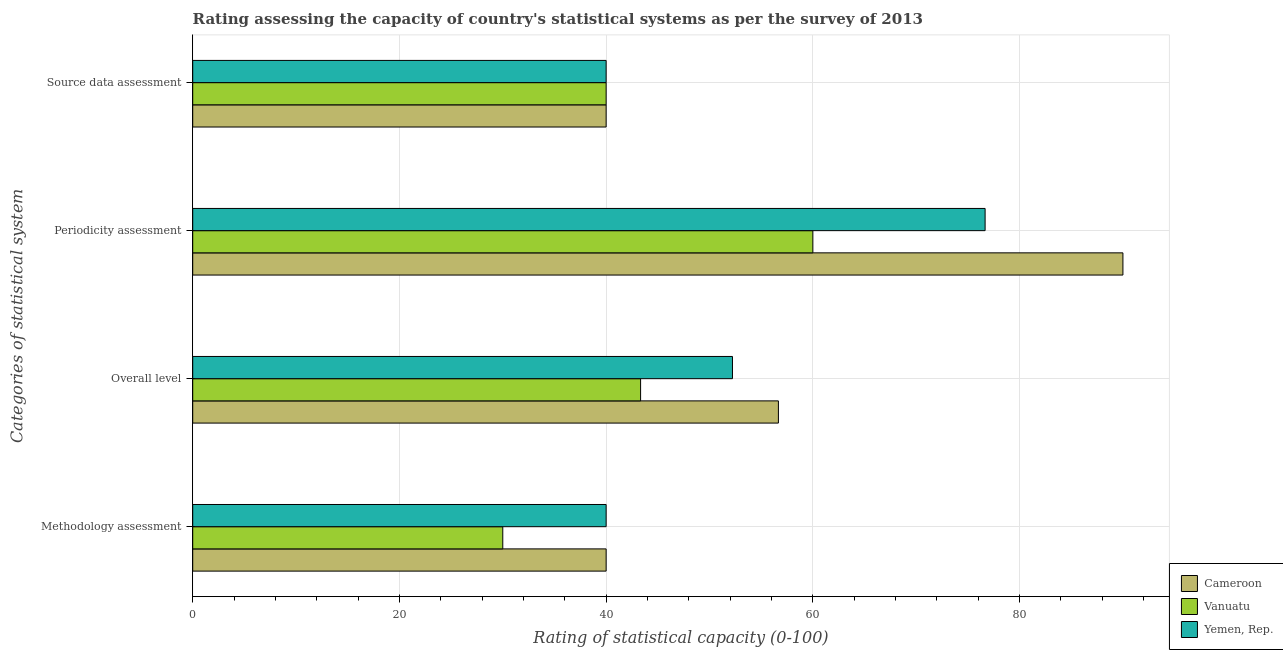How many groups of bars are there?
Provide a succinct answer. 4. Are the number of bars per tick equal to the number of legend labels?
Give a very brief answer. Yes. How many bars are there on the 3rd tick from the bottom?
Ensure brevity in your answer.  3. What is the label of the 2nd group of bars from the top?
Ensure brevity in your answer.  Periodicity assessment. What is the periodicity assessment rating in Yemen, Rep.?
Ensure brevity in your answer.  76.67. Across all countries, what is the minimum source data assessment rating?
Make the answer very short. 40. In which country was the methodology assessment rating maximum?
Provide a short and direct response. Cameroon. In which country was the overall level rating minimum?
Your answer should be compact. Vanuatu. What is the total overall level rating in the graph?
Your answer should be very brief. 152.22. What is the difference between the source data assessment rating in Cameroon and that in Vanuatu?
Give a very brief answer. 0. What is the difference between the methodology assessment rating in Cameroon and the periodicity assessment rating in Yemen, Rep.?
Provide a short and direct response. -36.67. What is the average methodology assessment rating per country?
Provide a short and direct response. 36.67. What is the difference between the overall level rating and source data assessment rating in Vanuatu?
Offer a terse response. 3.33. What is the ratio of the source data assessment rating in Cameroon to that in Yemen, Rep.?
Provide a succinct answer. 1. Is the overall level rating in Yemen, Rep. less than that in Cameroon?
Ensure brevity in your answer.  Yes. What is the difference between the highest and the second highest periodicity assessment rating?
Keep it short and to the point. 13.33. In how many countries, is the overall level rating greater than the average overall level rating taken over all countries?
Ensure brevity in your answer.  2. Is the sum of the periodicity assessment rating in Cameroon and Yemen, Rep. greater than the maximum methodology assessment rating across all countries?
Provide a succinct answer. Yes. Is it the case that in every country, the sum of the overall level rating and periodicity assessment rating is greater than the sum of methodology assessment rating and source data assessment rating?
Keep it short and to the point. No. What does the 1st bar from the top in Overall level represents?
Give a very brief answer. Yemen, Rep. What does the 3rd bar from the bottom in Periodicity assessment represents?
Make the answer very short. Yemen, Rep. How many bars are there?
Your answer should be very brief. 12. Are all the bars in the graph horizontal?
Your answer should be very brief. Yes. What is the difference between two consecutive major ticks on the X-axis?
Make the answer very short. 20. Does the graph contain grids?
Give a very brief answer. Yes. How many legend labels are there?
Ensure brevity in your answer.  3. How are the legend labels stacked?
Provide a short and direct response. Vertical. What is the title of the graph?
Offer a very short reply. Rating assessing the capacity of country's statistical systems as per the survey of 2013 . Does "Equatorial Guinea" appear as one of the legend labels in the graph?
Your response must be concise. No. What is the label or title of the X-axis?
Your response must be concise. Rating of statistical capacity (0-100). What is the label or title of the Y-axis?
Provide a short and direct response. Categories of statistical system. What is the Rating of statistical capacity (0-100) in Vanuatu in Methodology assessment?
Provide a succinct answer. 30. What is the Rating of statistical capacity (0-100) in Yemen, Rep. in Methodology assessment?
Keep it short and to the point. 40. What is the Rating of statistical capacity (0-100) of Cameroon in Overall level?
Provide a succinct answer. 56.67. What is the Rating of statistical capacity (0-100) of Vanuatu in Overall level?
Give a very brief answer. 43.33. What is the Rating of statistical capacity (0-100) of Yemen, Rep. in Overall level?
Your response must be concise. 52.22. What is the Rating of statistical capacity (0-100) of Cameroon in Periodicity assessment?
Your answer should be very brief. 90. What is the Rating of statistical capacity (0-100) in Vanuatu in Periodicity assessment?
Provide a short and direct response. 60. What is the Rating of statistical capacity (0-100) of Yemen, Rep. in Periodicity assessment?
Offer a terse response. 76.67. What is the Rating of statistical capacity (0-100) in Vanuatu in Source data assessment?
Keep it short and to the point. 40. Across all Categories of statistical system, what is the maximum Rating of statistical capacity (0-100) in Yemen, Rep.?
Your answer should be very brief. 76.67. Across all Categories of statistical system, what is the minimum Rating of statistical capacity (0-100) in Cameroon?
Provide a short and direct response. 40. Across all Categories of statistical system, what is the minimum Rating of statistical capacity (0-100) of Vanuatu?
Ensure brevity in your answer.  30. Across all Categories of statistical system, what is the minimum Rating of statistical capacity (0-100) in Yemen, Rep.?
Offer a terse response. 40. What is the total Rating of statistical capacity (0-100) in Cameroon in the graph?
Make the answer very short. 226.67. What is the total Rating of statistical capacity (0-100) in Vanuatu in the graph?
Keep it short and to the point. 173.33. What is the total Rating of statistical capacity (0-100) of Yemen, Rep. in the graph?
Your answer should be very brief. 208.89. What is the difference between the Rating of statistical capacity (0-100) of Cameroon in Methodology assessment and that in Overall level?
Your response must be concise. -16.67. What is the difference between the Rating of statistical capacity (0-100) of Vanuatu in Methodology assessment and that in Overall level?
Ensure brevity in your answer.  -13.33. What is the difference between the Rating of statistical capacity (0-100) in Yemen, Rep. in Methodology assessment and that in Overall level?
Keep it short and to the point. -12.22. What is the difference between the Rating of statistical capacity (0-100) of Vanuatu in Methodology assessment and that in Periodicity assessment?
Your answer should be very brief. -30. What is the difference between the Rating of statistical capacity (0-100) of Yemen, Rep. in Methodology assessment and that in Periodicity assessment?
Your answer should be very brief. -36.67. What is the difference between the Rating of statistical capacity (0-100) in Cameroon in Methodology assessment and that in Source data assessment?
Keep it short and to the point. 0. What is the difference between the Rating of statistical capacity (0-100) in Vanuatu in Methodology assessment and that in Source data assessment?
Offer a very short reply. -10. What is the difference between the Rating of statistical capacity (0-100) of Yemen, Rep. in Methodology assessment and that in Source data assessment?
Offer a terse response. 0. What is the difference between the Rating of statistical capacity (0-100) in Cameroon in Overall level and that in Periodicity assessment?
Offer a very short reply. -33.33. What is the difference between the Rating of statistical capacity (0-100) in Vanuatu in Overall level and that in Periodicity assessment?
Make the answer very short. -16.67. What is the difference between the Rating of statistical capacity (0-100) of Yemen, Rep. in Overall level and that in Periodicity assessment?
Your answer should be very brief. -24.44. What is the difference between the Rating of statistical capacity (0-100) in Cameroon in Overall level and that in Source data assessment?
Ensure brevity in your answer.  16.67. What is the difference between the Rating of statistical capacity (0-100) of Vanuatu in Overall level and that in Source data assessment?
Provide a short and direct response. 3.33. What is the difference between the Rating of statistical capacity (0-100) in Yemen, Rep. in Overall level and that in Source data assessment?
Your response must be concise. 12.22. What is the difference between the Rating of statistical capacity (0-100) of Vanuatu in Periodicity assessment and that in Source data assessment?
Your response must be concise. 20. What is the difference between the Rating of statistical capacity (0-100) in Yemen, Rep. in Periodicity assessment and that in Source data assessment?
Ensure brevity in your answer.  36.67. What is the difference between the Rating of statistical capacity (0-100) in Cameroon in Methodology assessment and the Rating of statistical capacity (0-100) in Vanuatu in Overall level?
Keep it short and to the point. -3.33. What is the difference between the Rating of statistical capacity (0-100) in Cameroon in Methodology assessment and the Rating of statistical capacity (0-100) in Yemen, Rep. in Overall level?
Keep it short and to the point. -12.22. What is the difference between the Rating of statistical capacity (0-100) of Vanuatu in Methodology assessment and the Rating of statistical capacity (0-100) of Yemen, Rep. in Overall level?
Ensure brevity in your answer.  -22.22. What is the difference between the Rating of statistical capacity (0-100) of Cameroon in Methodology assessment and the Rating of statistical capacity (0-100) of Yemen, Rep. in Periodicity assessment?
Provide a succinct answer. -36.67. What is the difference between the Rating of statistical capacity (0-100) in Vanuatu in Methodology assessment and the Rating of statistical capacity (0-100) in Yemen, Rep. in Periodicity assessment?
Keep it short and to the point. -46.67. What is the difference between the Rating of statistical capacity (0-100) of Cameroon in Methodology assessment and the Rating of statistical capacity (0-100) of Vanuatu in Source data assessment?
Your answer should be compact. 0. What is the difference between the Rating of statistical capacity (0-100) of Cameroon in Overall level and the Rating of statistical capacity (0-100) of Vanuatu in Periodicity assessment?
Provide a succinct answer. -3.33. What is the difference between the Rating of statistical capacity (0-100) in Cameroon in Overall level and the Rating of statistical capacity (0-100) in Yemen, Rep. in Periodicity assessment?
Provide a succinct answer. -20. What is the difference between the Rating of statistical capacity (0-100) in Vanuatu in Overall level and the Rating of statistical capacity (0-100) in Yemen, Rep. in Periodicity assessment?
Offer a very short reply. -33.33. What is the difference between the Rating of statistical capacity (0-100) of Cameroon in Overall level and the Rating of statistical capacity (0-100) of Vanuatu in Source data assessment?
Make the answer very short. 16.67. What is the difference between the Rating of statistical capacity (0-100) in Cameroon in Overall level and the Rating of statistical capacity (0-100) in Yemen, Rep. in Source data assessment?
Ensure brevity in your answer.  16.67. What is the difference between the Rating of statistical capacity (0-100) of Vanuatu in Overall level and the Rating of statistical capacity (0-100) of Yemen, Rep. in Source data assessment?
Make the answer very short. 3.33. What is the difference between the Rating of statistical capacity (0-100) of Cameroon in Periodicity assessment and the Rating of statistical capacity (0-100) of Vanuatu in Source data assessment?
Your answer should be compact. 50. What is the difference between the Rating of statistical capacity (0-100) in Cameroon in Periodicity assessment and the Rating of statistical capacity (0-100) in Yemen, Rep. in Source data assessment?
Keep it short and to the point. 50. What is the difference between the Rating of statistical capacity (0-100) in Vanuatu in Periodicity assessment and the Rating of statistical capacity (0-100) in Yemen, Rep. in Source data assessment?
Provide a short and direct response. 20. What is the average Rating of statistical capacity (0-100) in Cameroon per Categories of statistical system?
Your answer should be very brief. 56.67. What is the average Rating of statistical capacity (0-100) of Vanuatu per Categories of statistical system?
Provide a succinct answer. 43.33. What is the average Rating of statistical capacity (0-100) in Yemen, Rep. per Categories of statistical system?
Ensure brevity in your answer.  52.22. What is the difference between the Rating of statistical capacity (0-100) in Cameroon and Rating of statistical capacity (0-100) in Vanuatu in Methodology assessment?
Your answer should be compact. 10. What is the difference between the Rating of statistical capacity (0-100) of Cameroon and Rating of statistical capacity (0-100) of Yemen, Rep. in Methodology assessment?
Offer a very short reply. 0. What is the difference between the Rating of statistical capacity (0-100) in Cameroon and Rating of statistical capacity (0-100) in Vanuatu in Overall level?
Provide a succinct answer. 13.33. What is the difference between the Rating of statistical capacity (0-100) in Cameroon and Rating of statistical capacity (0-100) in Yemen, Rep. in Overall level?
Make the answer very short. 4.44. What is the difference between the Rating of statistical capacity (0-100) of Vanuatu and Rating of statistical capacity (0-100) of Yemen, Rep. in Overall level?
Provide a short and direct response. -8.89. What is the difference between the Rating of statistical capacity (0-100) in Cameroon and Rating of statistical capacity (0-100) in Yemen, Rep. in Periodicity assessment?
Provide a succinct answer. 13.33. What is the difference between the Rating of statistical capacity (0-100) in Vanuatu and Rating of statistical capacity (0-100) in Yemen, Rep. in Periodicity assessment?
Give a very brief answer. -16.67. What is the difference between the Rating of statistical capacity (0-100) in Cameroon and Rating of statistical capacity (0-100) in Vanuatu in Source data assessment?
Offer a terse response. 0. What is the difference between the Rating of statistical capacity (0-100) of Cameroon and Rating of statistical capacity (0-100) of Yemen, Rep. in Source data assessment?
Offer a very short reply. 0. What is the ratio of the Rating of statistical capacity (0-100) in Cameroon in Methodology assessment to that in Overall level?
Make the answer very short. 0.71. What is the ratio of the Rating of statistical capacity (0-100) in Vanuatu in Methodology assessment to that in Overall level?
Provide a succinct answer. 0.69. What is the ratio of the Rating of statistical capacity (0-100) of Yemen, Rep. in Methodology assessment to that in Overall level?
Keep it short and to the point. 0.77. What is the ratio of the Rating of statistical capacity (0-100) of Cameroon in Methodology assessment to that in Periodicity assessment?
Ensure brevity in your answer.  0.44. What is the ratio of the Rating of statistical capacity (0-100) of Yemen, Rep. in Methodology assessment to that in Periodicity assessment?
Your answer should be compact. 0.52. What is the ratio of the Rating of statistical capacity (0-100) in Vanuatu in Methodology assessment to that in Source data assessment?
Give a very brief answer. 0.75. What is the ratio of the Rating of statistical capacity (0-100) in Cameroon in Overall level to that in Periodicity assessment?
Your response must be concise. 0.63. What is the ratio of the Rating of statistical capacity (0-100) of Vanuatu in Overall level to that in Periodicity assessment?
Provide a short and direct response. 0.72. What is the ratio of the Rating of statistical capacity (0-100) in Yemen, Rep. in Overall level to that in Periodicity assessment?
Your response must be concise. 0.68. What is the ratio of the Rating of statistical capacity (0-100) in Cameroon in Overall level to that in Source data assessment?
Make the answer very short. 1.42. What is the ratio of the Rating of statistical capacity (0-100) of Vanuatu in Overall level to that in Source data assessment?
Provide a succinct answer. 1.08. What is the ratio of the Rating of statistical capacity (0-100) of Yemen, Rep. in Overall level to that in Source data assessment?
Make the answer very short. 1.31. What is the ratio of the Rating of statistical capacity (0-100) of Cameroon in Periodicity assessment to that in Source data assessment?
Your answer should be very brief. 2.25. What is the ratio of the Rating of statistical capacity (0-100) in Yemen, Rep. in Periodicity assessment to that in Source data assessment?
Your answer should be compact. 1.92. What is the difference between the highest and the second highest Rating of statistical capacity (0-100) of Cameroon?
Make the answer very short. 33.33. What is the difference between the highest and the second highest Rating of statistical capacity (0-100) of Vanuatu?
Provide a succinct answer. 16.67. What is the difference between the highest and the second highest Rating of statistical capacity (0-100) in Yemen, Rep.?
Give a very brief answer. 24.44. What is the difference between the highest and the lowest Rating of statistical capacity (0-100) in Yemen, Rep.?
Ensure brevity in your answer.  36.67. 